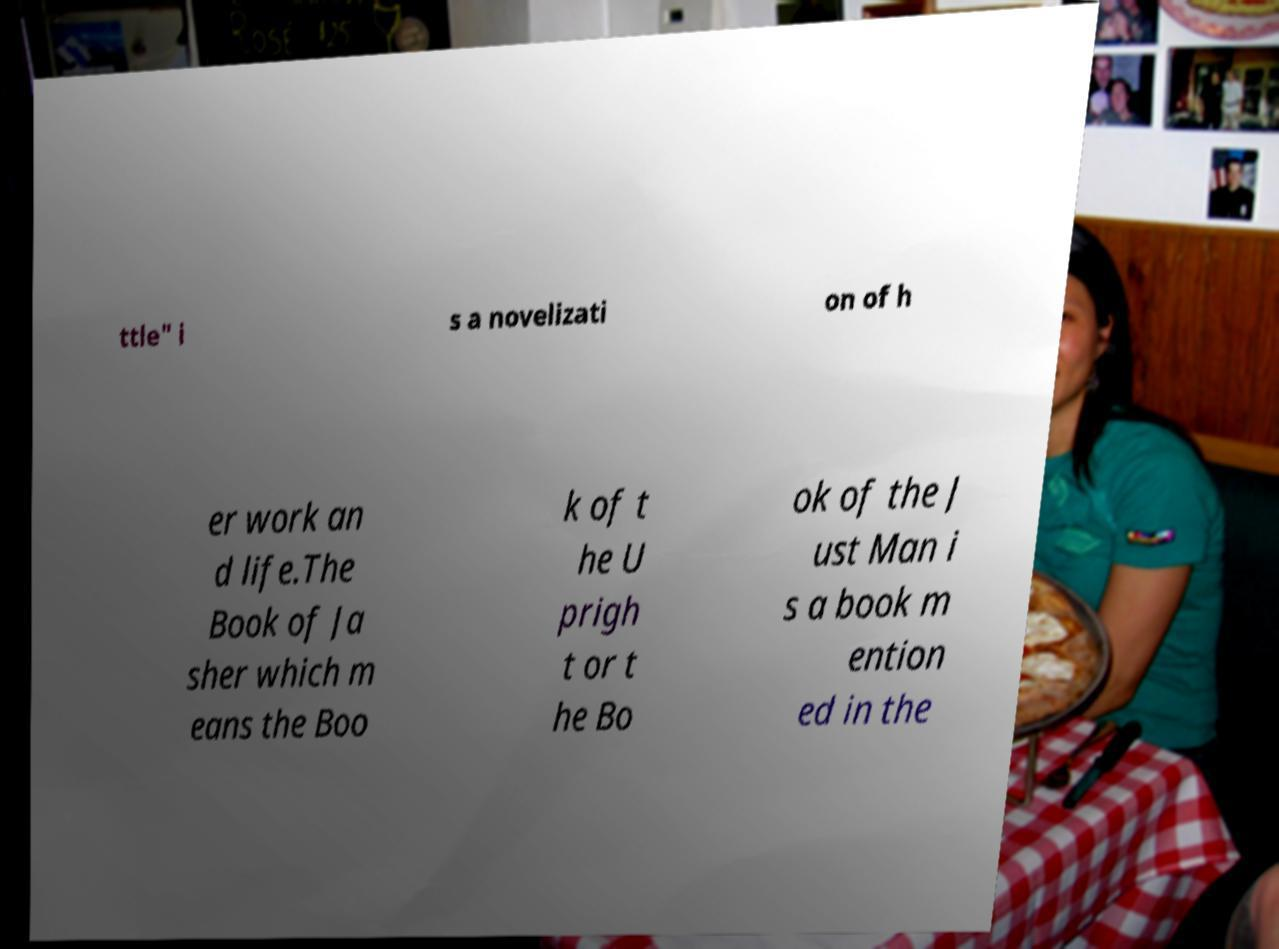Could you extract and type out the text from this image? ttle" i s a novelizati on of h er work an d life.The Book of Ja sher which m eans the Boo k of t he U prigh t or t he Bo ok of the J ust Man i s a book m ention ed in the 